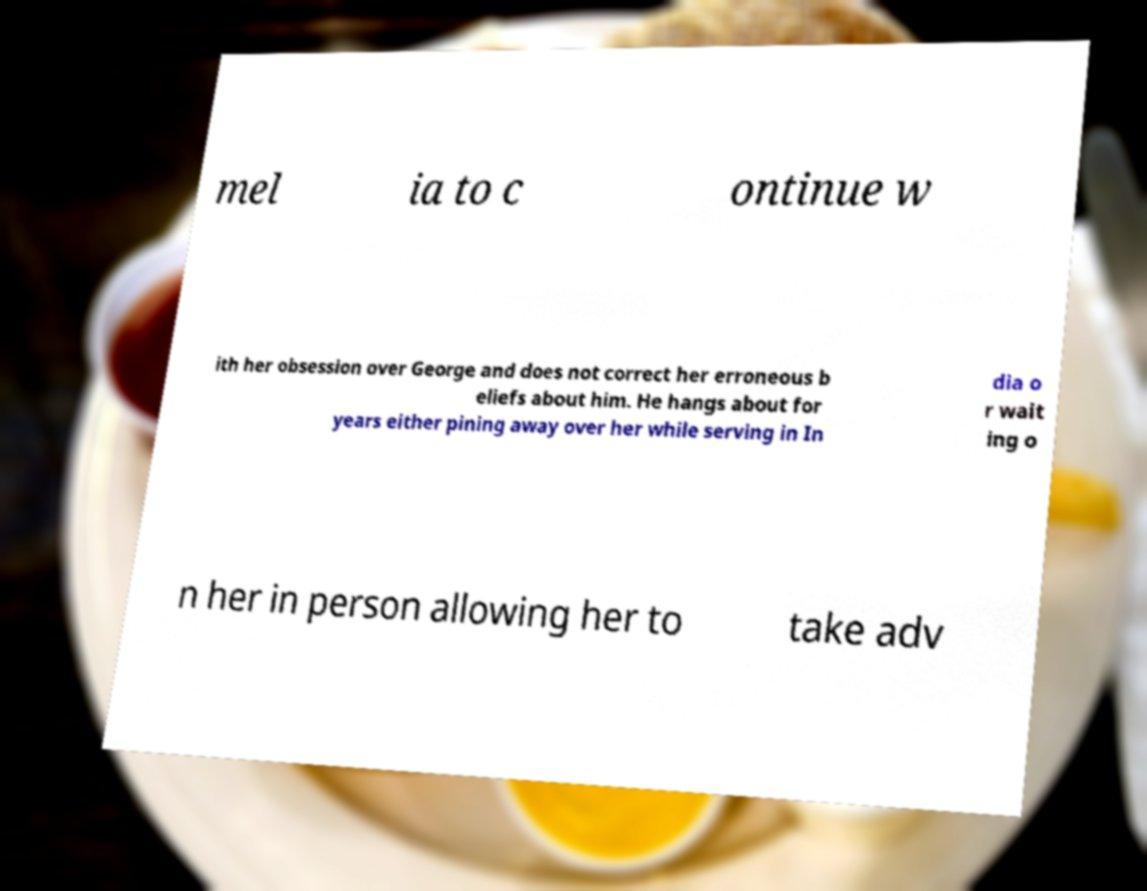Could you assist in decoding the text presented in this image and type it out clearly? mel ia to c ontinue w ith her obsession over George and does not correct her erroneous b eliefs about him. He hangs about for years either pining away over her while serving in In dia o r wait ing o n her in person allowing her to take adv 